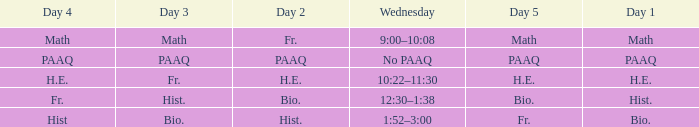What is the day 3 when day 4 is fr.? Hist. 